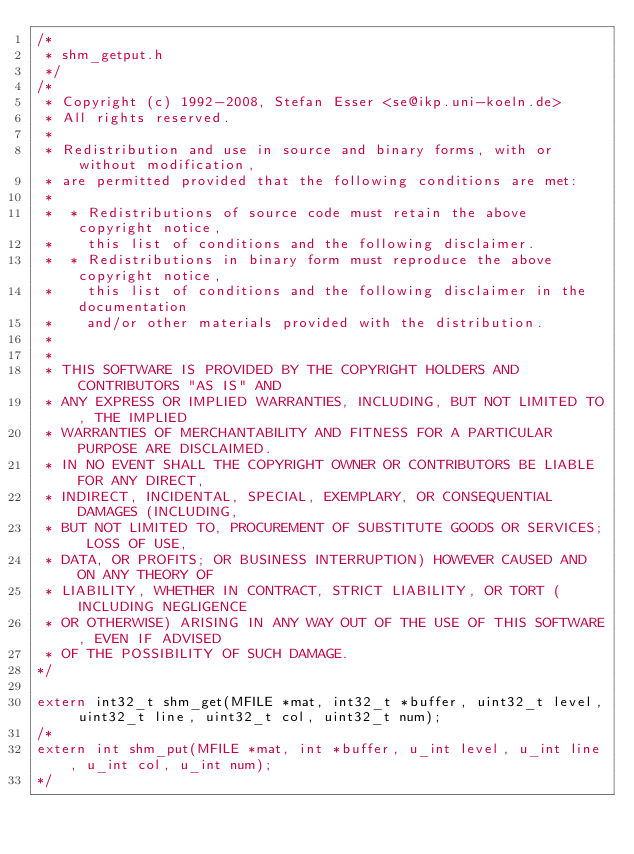<code> <loc_0><loc_0><loc_500><loc_500><_C_>/*
 * shm_getput.h
 */
/*
 * Copyright (c) 1992-2008, Stefan Esser <se@ikp.uni-koeln.de>
 * All rights reserved.
 * 
 * Redistribution and use in source and binary forms, with or without modification, 
 * are permitted provided that the following conditions are met:
 * 
 *	* Redistributions of source code must retain the above copyright notice, 
 *	  this list of conditions and the following disclaimer.
 * 	* Redistributions in binary form must reproduce the above copyright notice, 
 * 	  this list of conditions and the following disclaimer in the documentation 
 * 	  and/or other materials provided with the distribution.
 *    
 *
 * THIS SOFTWARE IS PROVIDED BY THE COPYRIGHT HOLDERS AND CONTRIBUTORS "AS IS" AND 
 * ANY EXPRESS OR IMPLIED WARRANTIES, INCLUDING, BUT NOT LIMITED TO, THE IMPLIED 
 * WARRANTIES OF MERCHANTABILITY AND FITNESS FOR A PARTICULAR PURPOSE ARE DISCLAIMED. 
 * IN NO EVENT SHALL THE COPYRIGHT OWNER OR CONTRIBUTORS BE LIABLE FOR ANY DIRECT, 
 * INDIRECT, INCIDENTAL, SPECIAL, EXEMPLARY, OR CONSEQUENTIAL DAMAGES (INCLUDING, 
 * BUT NOT LIMITED TO, PROCUREMENT OF SUBSTITUTE GOODS OR SERVICES; LOSS OF USE, 
 * DATA, OR PROFITS; OR BUSINESS INTERRUPTION) HOWEVER CAUSED AND ON ANY THEORY OF
 * LIABILITY, WHETHER IN CONTRACT, STRICT LIABILITY, OR TORT (INCLUDING NEGLIGENCE 
 * OR OTHERWISE) ARISING IN ANY WAY OUT OF THE USE OF THIS SOFTWARE, EVEN IF ADVISED 
 * OF THE POSSIBILITY OF SUCH DAMAGE.
*/

extern int32_t shm_get(MFILE *mat, int32_t *buffer, uint32_t level, uint32_t line, uint32_t col, uint32_t num);
/*
extern int shm_put(MFILE *mat, int *buffer, u_int level, u_int line, u_int col, u_int num);
*/
</code> 